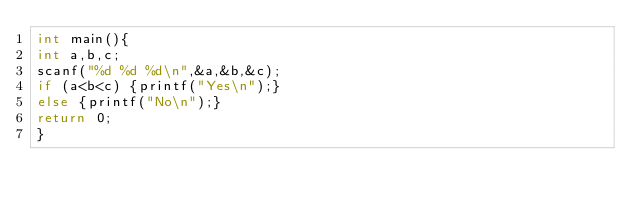<code> <loc_0><loc_0><loc_500><loc_500><_C_>int main(){
int a,b,c;
scanf("%d %d %d\n",&a,&b,&c);
if (a<b<c) {printf("Yes\n");}
else {printf("No\n");}
return 0;
}</code> 